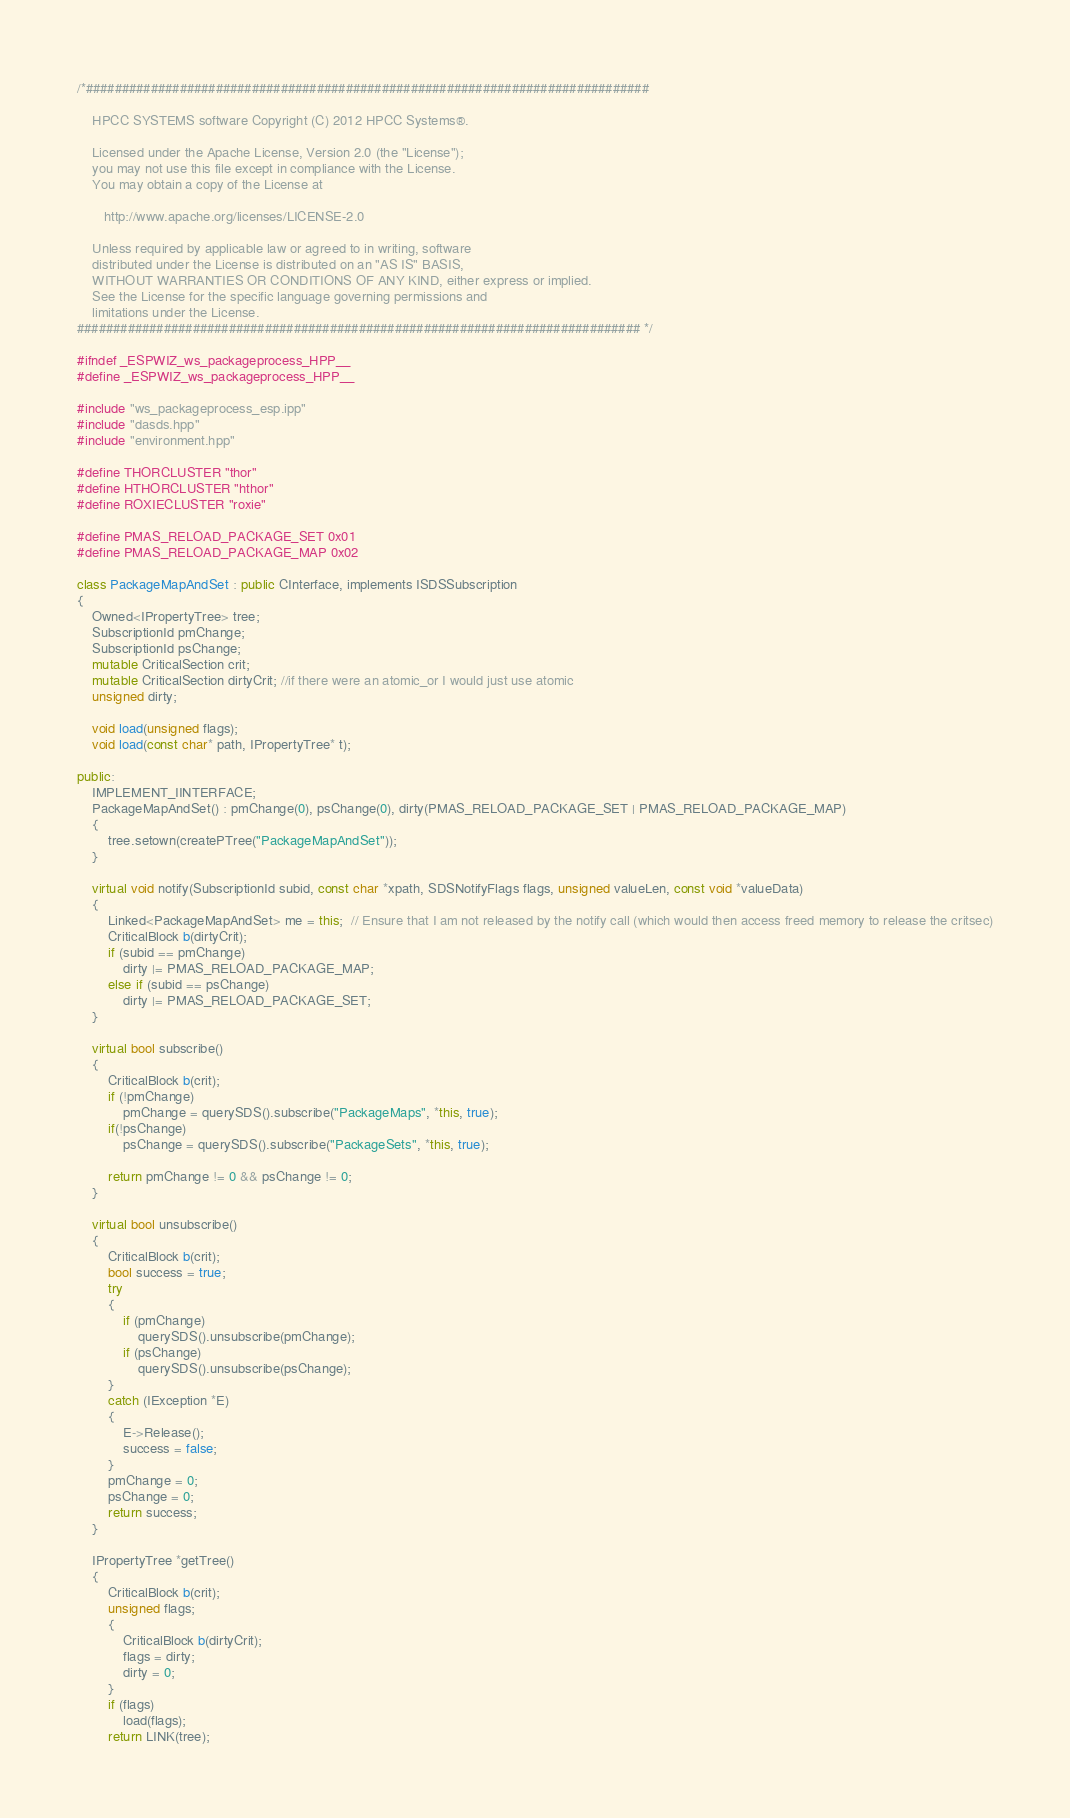<code> <loc_0><loc_0><loc_500><loc_500><_C++_>/*##############################################################################

    HPCC SYSTEMS software Copyright (C) 2012 HPCC Systems®.

    Licensed under the Apache License, Version 2.0 (the "License");
    you may not use this file except in compliance with the License.
    You may obtain a copy of the License at

       http://www.apache.org/licenses/LICENSE-2.0

    Unless required by applicable law or agreed to in writing, software
    distributed under the License is distributed on an "AS IS" BASIS,
    WITHOUT WARRANTIES OR CONDITIONS OF ANY KIND, either express or implied.
    See the License for the specific language governing permissions and
    limitations under the License.
############################################################################## */

#ifndef _ESPWIZ_ws_packageprocess_HPP__
#define _ESPWIZ_ws_packageprocess_HPP__

#include "ws_packageprocess_esp.ipp"
#include "dasds.hpp"
#include "environment.hpp"

#define THORCLUSTER "thor"
#define HTHORCLUSTER "hthor"
#define ROXIECLUSTER "roxie"

#define PMAS_RELOAD_PACKAGE_SET 0x01
#define PMAS_RELOAD_PACKAGE_MAP 0x02

class PackageMapAndSet : public CInterface, implements ISDSSubscription
{
    Owned<IPropertyTree> tree;
    SubscriptionId pmChange;
    SubscriptionId psChange;
    mutable CriticalSection crit;
    mutable CriticalSection dirtyCrit; //if there were an atomic_or I would just use atomic
    unsigned dirty;

    void load(unsigned flags);
    void load(const char* path, IPropertyTree* t);

public:
    IMPLEMENT_IINTERFACE;
    PackageMapAndSet() : pmChange(0), psChange(0), dirty(PMAS_RELOAD_PACKAGE_SET | PMAS_RELOAD_PACKAGE_MAP)
    {
        tree.setown(createPTree("PackageMapAndSet"));
    }

    virtual void notify(SubscriptionId subid, const char *xpath, SDSNotifyFlags flags, unsigned valueLen, const void *valueData)
    {
        Linked<PackageMapAndSet> me = this;  // Ensure that I am not released by the notify call (which would then access freed memory to release the critsec)
        CriticalBlock b(dirtyCrit);
        if (subid == pmChange)
            dirty |= PMAS_RELOAD_PACKAGE_MAP;
        else if (subid == psChange)
            dirty |= PMAS_RELOAD_PACKAGE_SET;
    }

    virtual bool subscribe()
    {
        CriticalBlock b(crit);
        if (!pmChange)
            pmChange = querySDS().subscribe("PackageMaps", *this, true);
        if(!psChange)
            psChange = querySDS().subscribe("PackageSets", *this, true);

        return pmChange != 0 && psChange != 0;
    }

    virtual bool unsubscribe()
    {
        CriticalBlock b(crit);
        bool success = true;
        try
        {
            if (pmChange)
                querySDS().unsubscribe(pmChange);
            if (psChange)
                querySDS().unsubscribe(psChange);
        }
        catch (IException *E)
        {
            E->Release();
            success = false;
        }
        pmChange = 0;
        psChange = 0;
        return success;
    }

    IPropertyTree *getTree()
    {
        CriticalBlock b(crit);
        unsigned flags;
        {
            CriticalBlock b(dirtyCrit);
            flags = dirty;
            dirty = 0;
        }
        if (flags)
            load(flags);
        return LINK(tree);</code> 